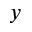<formula> <loc_0><loc_0><loc_500><loc_500>y</formula> 